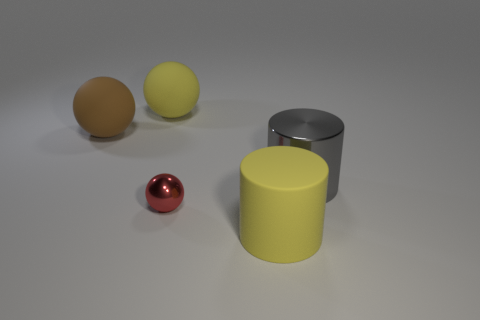There is a matte object that is the same color as the rubber cylinder; what is its shape?
Provide a short and direct response. Sphere. What shape is the brown object that is the same size as the gray object?
Offer a very short reply. Sphere. Are there fewer red shiny things than tiny gray metal objects?
Ensure brevity in your answer.  No. There is a large yellow thing left of the big matte cylinder; are there any brown objects behind it?
Offer a terse response. No. The other object that is made of the same material as the small thing is what shape?
Offer a very short reply. Cylinder. Is there anything else of the same color as the matte cylinder?
Offer a very short reply. Yes. What is the material of the large brown thing that is the same shape as the small object?
Your answer should be very brief. Rubber. How many other things are there of the same size as the gray shiny cylinder?
Offer a very short reply. 3. What size is the matte thing that is the same color as the large rubber cylinder?
Make the answer very short. Large. There is a large yellow object in front of the red object; is it the same shape as the brown object?
Your response must be concise. No. 